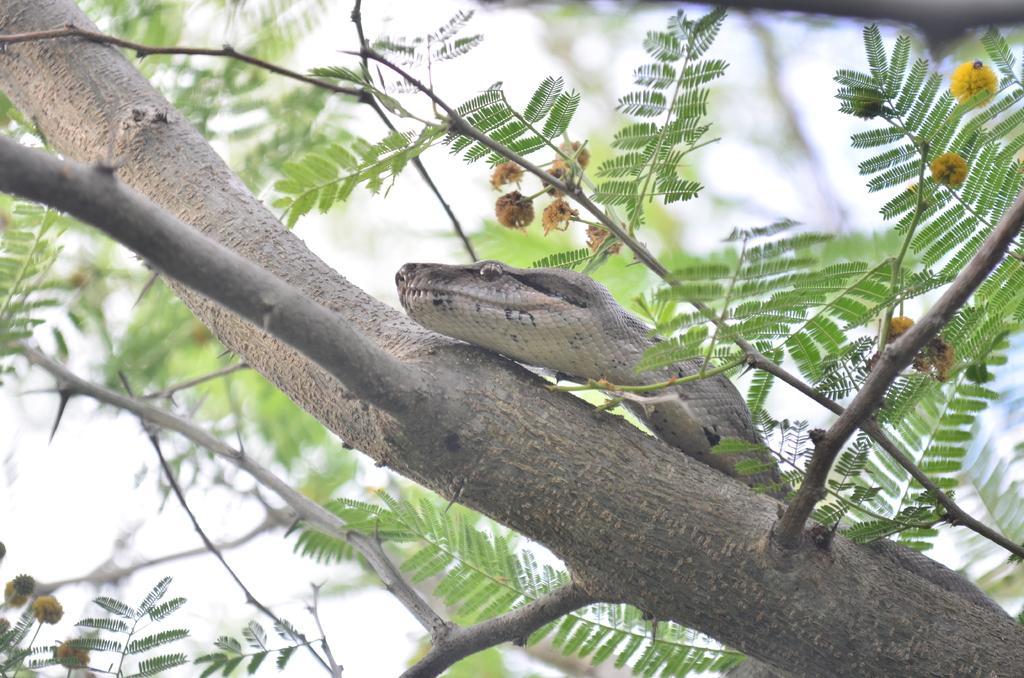Could you give a brief overview of what you see in this image? In this image, we can see a snake on the tree. We can also see the sky. 